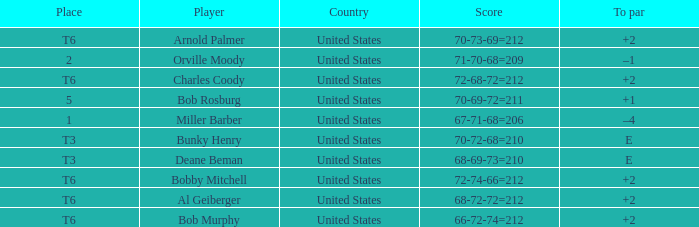Who is the player with a t6 place and a 72-68-72=212 score? Charles Coody. 